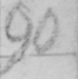Can you read and transcribe this handwriting? Letter 2d or 3 